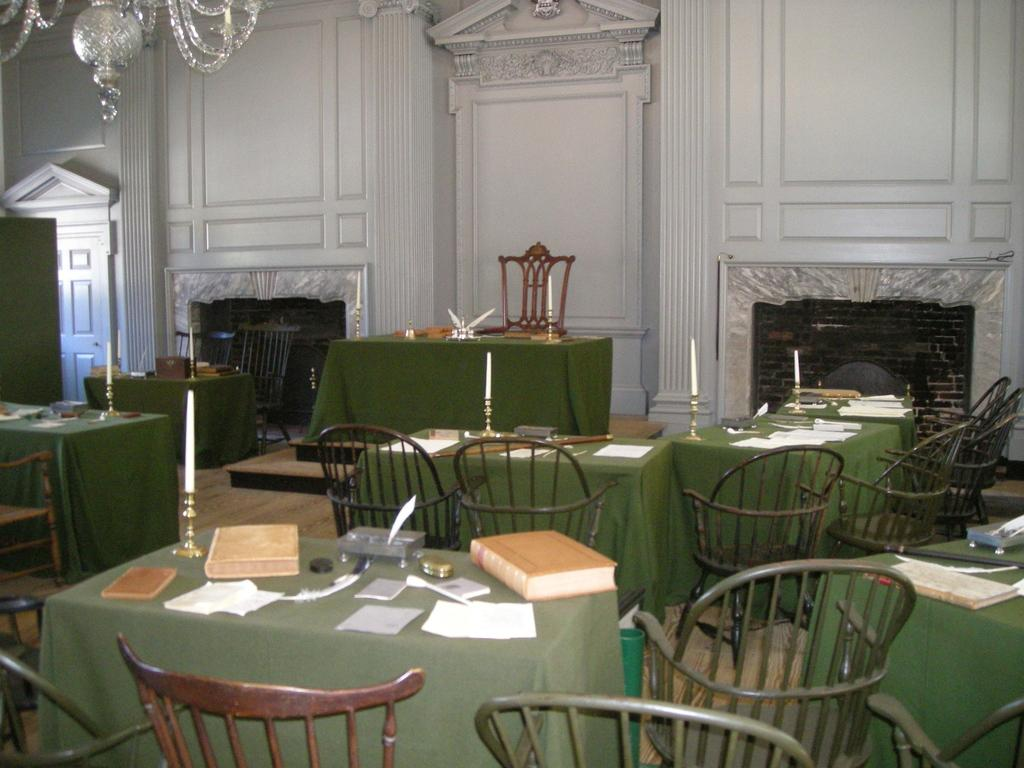What type of furniture is present in the image? There are chairs and tables in the image. What covers the tables in the image? Table cloths are present on the tables. What can be found on the tables in the image? Stationary and candles on candle holders are visible in the image. What type of lighting fixture is present in the image? A chandelier is present in the image. What architectural feature is visible in the image? There is a mantelpiece in the image. What type of surface is visible in the image? Walls are visible in the image. What type of rail can be seen in the image? There is no rail present in the image. What discovery was made in the image? There is no discovery mentioned or depicted in the image. 